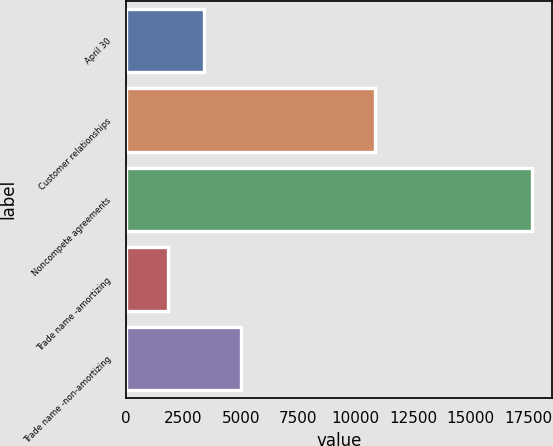Convert chart to OTSL. <chart><loc_0><loc_0><loc_500><loc_500><bar_chart><fcel>April 30<fcel>Customer relationships<fcel>Noncompete agreements<fcel>Trade name -amortizing<fcel>Trade name -non-amortizing<nl><fcel>3409.3<fcel>10842<fcel>17686<fcel>1823<fcel>4995.6<nl></chart> 